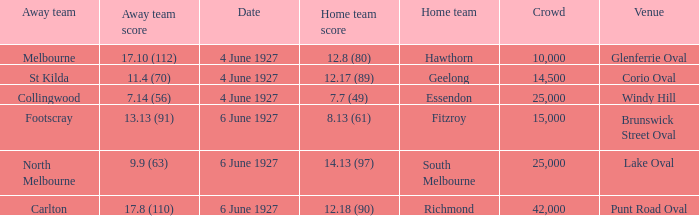How many people in the crowd with north melbourne as an away team? 25000.0. 